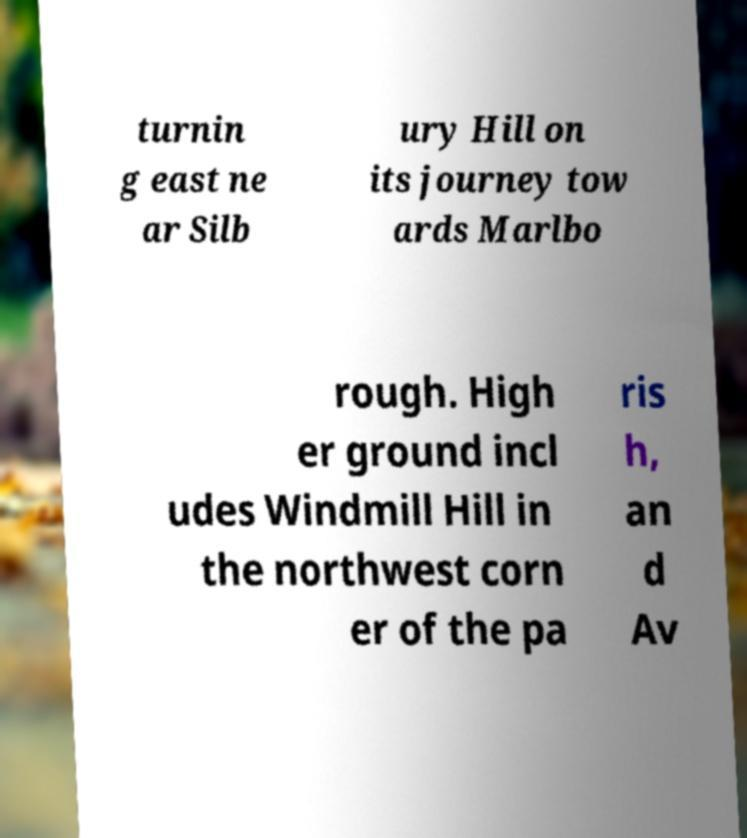Please read and relay the text visible in this image. What does it say? turnin g east ne ar Silb ury Hill on its journey tow ards Marlbo rough. High er ground incl udes Windmill Hill in the northwest corn er of the pa ris h, an d Av 